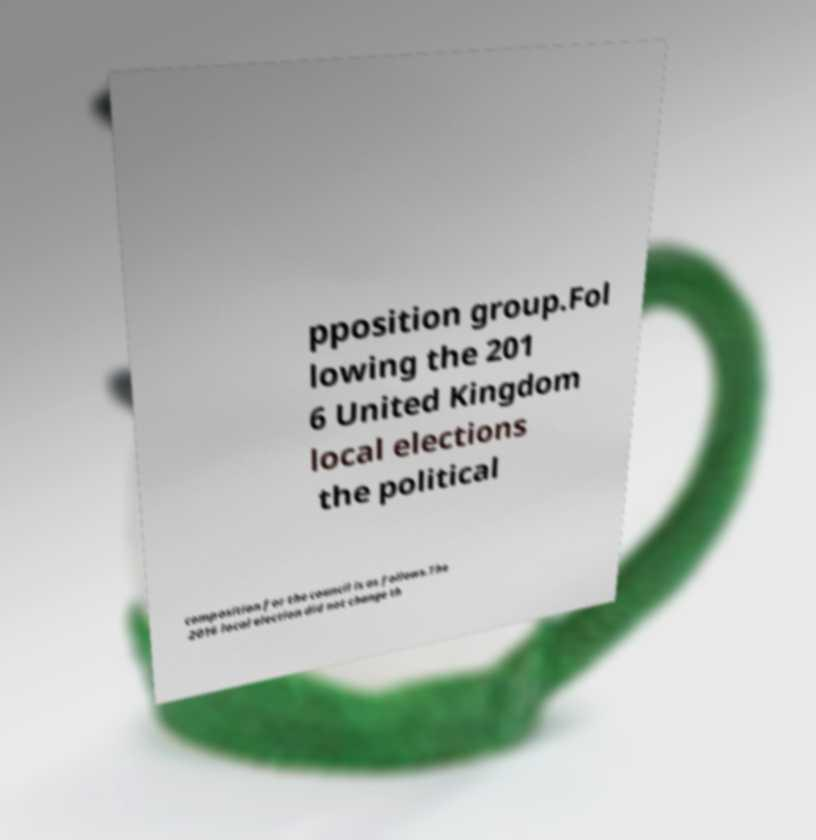Can you accurately transcribe the text from the provided image for me? pposition group.Fol lowing the 201 6 United Kingdom local elections the political composition for the council is as follows.The 2016 local election did not change th 